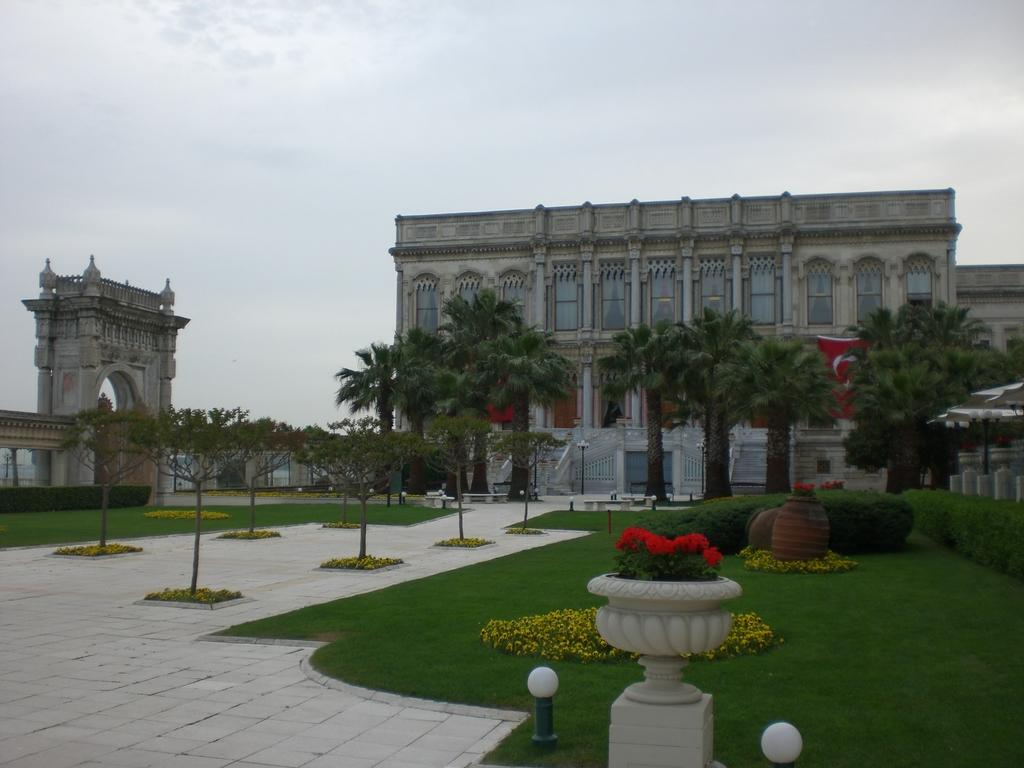What type of terrain is visible in the image? There is grassy land in the image. What structures can be seen in the image? Light poles, trees, potted plants, and buildings are present in the image. What is the condition of the sky in the image? The sky is covered with clouds at the top of the image. What type of music can be heard playing in the background of the image? There is no music present in the image, as it is a still photograph. 